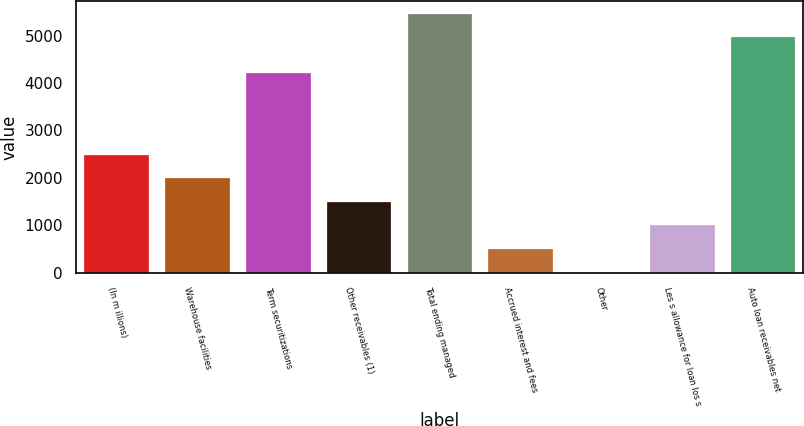Convert chart. <chart><loc_0><loc_0><loc_500><loc_500><bar_chart><fcel>(In m illions)<fcel>Warehouse facilities<fcel>Term securitizations<fcel>Other receivables (1)<fcel>Total ending managed<fcel>Accrued interest and fees<fcel>Other<fcel>Les s allowance for loan los s<fcel>Auto loan receivables net<nl><fcel>2491.8<fcel>1993.8<fcel>4211.8<fcel>1495.8<fcel>5457.8<fcel>499.8<fcel>1.8<fcel>997.8<fcel>4959.8<nl></chart> 